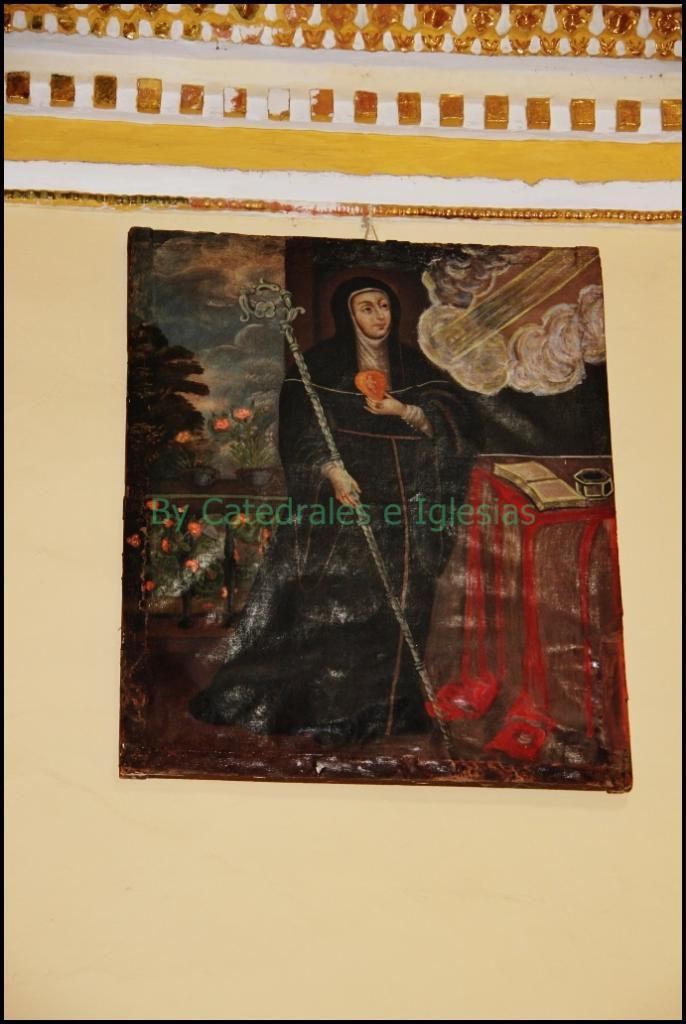What type of border surrounds the image? The image is framed, so it has a border made of a frame. Where is the frame located? The frame is attached to the wall. Is there any additional marking on the image? Yes, there is a watermark on the image. What type of zephyr can be seen blowing through the image? There is no zephyr present in the image, as a zephyr is a gentle breeze and not a visible object. 